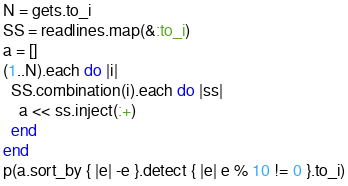<code> <loc_0><loc_0><loc_500><loc_500><_Ruby_>N = gets.to_i
SS = readlines.map(&:to_i)
a = []
(1..N).each do |i|
  SS.combination(i).each do |ss|
    a << ss.inject(:+)
  end
end
p(a.sort_by { |e| -e }.detect { |e| e % 10 != 0 }.to_i)</code> 